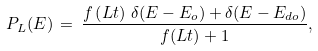Convert formula to latex. <formula><loc_0><loc_0><loc_500><loc_500>P _ { L } ( E ) \, = \, \frac { f \left ( L t \right ) \, \delta ( E - E _ { o } ) + \delta ( E - E _ { d o } ) } { f ( L t ) + 1 } ,</formula> 